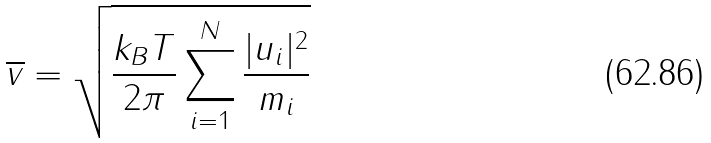<formula> <loc_0><loc_0><loc_500><loc_500>\overline { v } = \sqrt { \frac { k _ { B } T } { 2 \pi } \sum _ { i = 1 } ^ { N } \frac { | u _ { i } | ^ { 2 } } { m _ { i } } }</formula> 